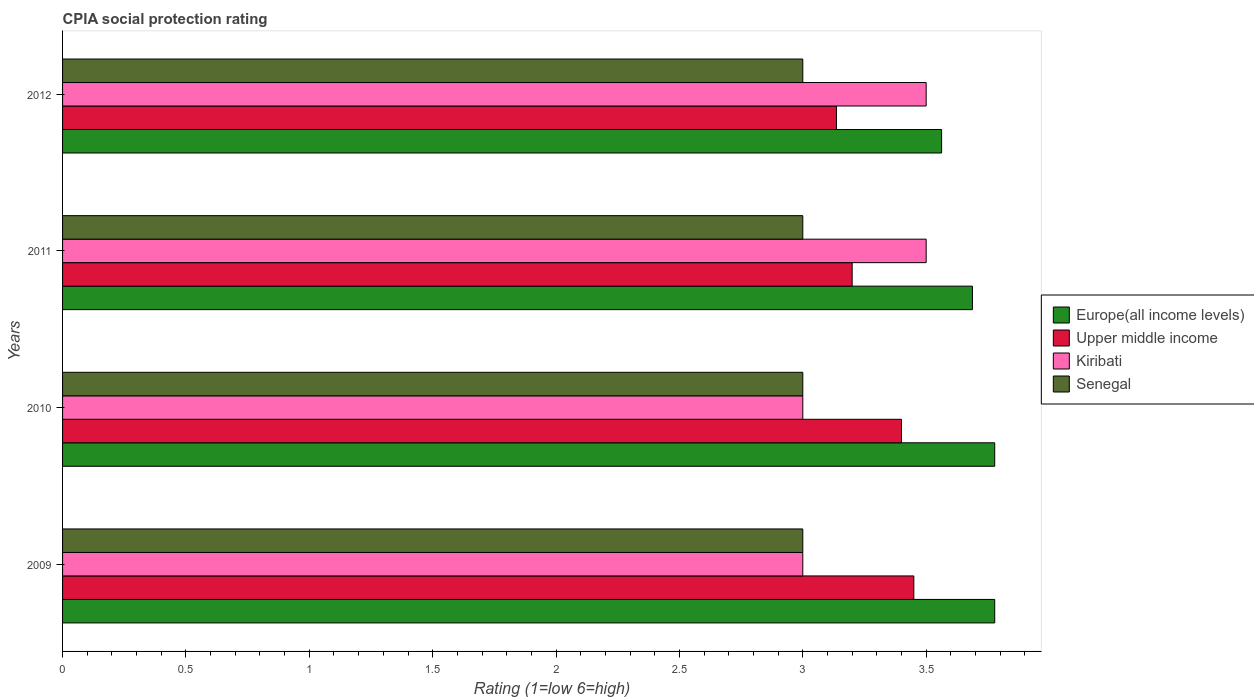Are the number of bars on each tick of the Y-axis equal?
Your answer should be very brief. Yes. How many bars are there on the 3rd tick from the bottom?
Offer a terse response. 4. In how many cases, is the number of bars for a given year not equal to the number of legend labels?
Provide a succinct answer. 0. What is the CPIA rating in Upper middle income in 2012?
Your response must be concise. 3.14. Across all years, what is the minimum CPIA rating in Senegal?
Make the answer very short. 3. In which year was the CPIA rating in Europe(all income levels) maximum?
Keep it short and to the point. 2009. What is the total CPIA rating in Senegal in the graph?
Give a very brief answer. 12. What is the difference between the CPIA rating in Upper middle income in 2009 and that in 2010?
Offer a terse response. 0.05. What is the difference between the CPIA rating in Upper middle income in 2009 and the CPIA rating in Kiribati in 2012?
Offer a terse response. -0.05. In the year 2011, what is the difference between the CPIA rating in Senegal and CPIA rating in Upper middle income?
Make the answer very short. -0.2. What is the ratio of the CPIA rating in Upper middle income in 2009 to that in 2012?
Ensure brevity in your answer.  1.1. What is the difference between the highest and the second highest CPIA rating in Upper middle income?
Offer a terse response. 0.05. What is the difference between the highest and the lowest CPIA rating in Upper middle income?
Provide a succinct answer. 0.31. Is the sum of the CPIA rating in Senegal in 2010 and 2012 greater than the maximum CPIA rating in Upper middle income across all years?
Offer a very short reply. Yes. Is it the case that in every year, the sum of the CPIA rating in Europe(all income levels) and CPIA rating in Senegal is greater than the sum of CPIA rating in Upper middle income and CPIA rating in Kiribati?
Your response must be concise. Yes. What does the 2nd bar from the top in 2011 represents?
Keep it short and to the point. Kiribati. What does the 1st bar from the bottom in 2009 represents?
Offer a very short reply. Europe(all income levels). Is it the case that in every year, the sum of the CPIA rating in Upper middle income and CPIA rating in Senegal is greater than the CPIA rating in Europe(all income levels)?
Keep it short and to the point. Yes. How many bars are there?
Provide a succinct answer. 16. Are all the bars in the graph horizontal?
Offer a terse response. Yes. What is the difference between two consecutive major ticks on the X-axis?
Make the answer very short. 0.5. Are the values on the major ticks of X-axis written in scientific E-notation?
Keep it short and to the point. No. Does the graph contain any zero values?
Ensure brevity in your answer.  No. Does the graph contain grids?
Give a very brief answer. No. How are the legend labels stacked?
Your answer should be compact. Vertical. What is the title of the graph?
Make the answer very short. CPIA social protection rating. Does "Cameroon" appear as one of the legend labels in the graph?
Give a very brief answer. No. What is the label or title of the Y-axis?
Make the answer very short. Years. What is the Rating (1=low 6=high) in Europe(all income levels) in 2009?
Your answer should be compact. 3.78. What is the Rating (1=low 6=high) in Upper middle income in 2009?
Your answer should be compact. 3.45. What is the Rating (1=low 6=high) of Kiribati in 2009?
Keep it short and to the point. 3. What is the Rating (1=low 6=high) of Senegal in 2009?
Make the answer very short. 3. What is the Rating (1=low 6=high) in Europe(all income levels) in 2010?
Your response must be concise. 3.78. What is the Rating (1=low 6=high) in Senegal in 2010?
Your response must be concise. 3. What is the Rating (1=low 6=high) of Europe(all income levels) in 2011?
Provide a succinct answer. 3.69. What is the Rating (1=low 6=high) in Kiribati in 2011?
Offer a very short reply. 3.5. What is the Rating (1=low 6=high) in Senegal in 2011?
Provide a short and direct response. 3. What is the Rating (1=low 6=high) of Europe(all income levels) in 2012?
Your response must be concise. 3.56. What is the Rating (1=low 6=high) of Upper middle income in 2012?
Provide a succinct answer. 3.14. Across all years, what is the maximum Rating (1=low 6=high) of Europe(all income levels)?
Your answer should be very brief. 3.78. Across all years, what is the maximum Rating (1=low 6=high) in Upper middle income?
Make the answer very short. 3.45. Across all years, what is the maximum Rating (1=low 6=high) in Kiribati?
Your answer should be compact. 3.5. Across all years, what is the maximum Rating (1=low 6=high) in Senegal?
Keep it short and to the point. 3. Across all years, what is the minimum Rating (1=low 6=high) of Europe(all income levels)?
Make the answer very short. 3.56. Across all years, what is the minimum Rating (1=low 6=high) of Upper middle income?
Your answer should be very brief. 3.14. Across all years, what is the minimum Rating (1=low 6=high) of Senegal?
Provide a succinct answer. 3. What is the total Rating (1=low 6=high) in Europe(all income levels) in the graph?
Ensure brevity in your answer.  14.81. What is the total Rating (1=low 6=high) of Upper middle income in the graph?
Keep it short and to the point. 13.19. What is the total Rating (1=low 6=high) in Kiribati in the graph?
Your response must be concise. 13. What is the difference between the Rating (1=low 6=high) of Upper middle income in 2009 and that in 2010?
Provide a short and direct response. 0.05. What is the difference between the Rating (1=low 6=high) of Kiribati in 2009 and that in 2010?
Your response must be concise. 0. What is the difference between the Rating (1=low 6=high) of Senegal in 2009 and that in 2010?
Keep it short and to the point. 0. What is the difference between the Rating (1=low 6=high) in Europe(all income levels) in 2009 and that in 2011?
Your answer should be very brief. 0.09. What is the difference between the Rating (1=low 6=high) in Senegal in 2009 and that in 2011?
Provide a short and direct response. 0. What is the difference between the Rating (1=low 6=high) of Europe(all income levels) in 2009 and that in 2012?
Keep it short and to the point. 0.22. What is the difference between the Rating (1=low 6=high) in Upper middle income in 2009 and that in 2012?
Keep it short and to the point. 0.31. What is the difference between the Rating (1=low 6=high) of Senegal in 2009 and that in 2012?
Your response must be concise. 0. What is the difference between the Rating (1=low 6=high) of Europe(all income levels) in 2010 and that in 2011?
Ensure brevity in your answer.  0.09. What is the difference between the Rating (1=low 6=high) of Upper middle income in 2010 and that in 2011?
Offer a terse response. 0.2. What is the difference between the Rating (1=low 6=high) of Senegal in 2010 and that in 2011?
Make the answer very short. 0. What is the difference between the Rating (1=low 6=high) in Europe(all income levels) in 2010 and that in 2012?
Your response must be concise. 0.22. What is the difference between the Rating (1=low 6=high) in Upper middle income in 2010 and that in 2012?
Keep it short and to the point. 0.26. What is the difference between the Rating (1=low 6=high) of Kiribati in 2010 and that in 2012?
Give a very brief answer. -0.5. What is the difference between the Rating (1=low 6=high) in Senegal in 2010 and that in 2012?
Offer a terse response. 0. What is the difference between the Rating (1=low 6=high) in Europe(all income levels) in 2011 and that in 2012?
Your response must be concise. 0.12. What is the difference between the Rating (1=low 6=high) in Upper middle income in 2011 and that in 2012?
Ensure brevity in your answer.  0.06. What is the difference between the Rating (1=low 6=high) of Kiribati in 2011 and that in 2012?
Give a very brief answer. 0. What is the difference between the Rating (1=low 6=high) in Europe(all income levels) in 2009 and the Rating (1=low 6=high) in Upper middle income in 2010?
Ensure brevity in your answer.  0.38. What is the difference between the Rating (1=low 6=high) of Europe(all income levels) in 2009 and the Rating (1=low 6=high) of Kiribati in 2010?
Provide a succinct answer. 0.78. What is the difference between the Rating (1=low 6=high) in Europe(all income levels) in 2009 and the Rating (1=low 6=high) in Senegal in 2010?
Keep it short and to the point. 0.78. What is the difference between the Rating (1=low 6=high) in Upper middle income in 2009 and the Rating (1=low 6=high) in Kiribati in 2010?
Your answer should be compact. 0.45. What is the difference between the Rating (1=low 6=high) in Upper middle income in 2009 and the Rating (1=low 6=high) in Senegal in 2010?
Offer a terse response. 0.45. What is the difference between the Rating (1=low 6=high) in Europe(all income levels) in 2009 and the Rating (1=low 6=high) in Upper middle income in 2011?
Offer a very short reply. 0.58. What is the difference between the Rating (1=low 6=high) in Europe(all income levels) in 2009 and the Rating (1=low 6=high) in Kiribati in 2011?
Offer a terse response. 0.28. What is the difference between the Rating (1=low 6=high) in Europe(all income levels) in 2009 and the Rating (1=low 6=high) in Senegal in 2011?
Your answer should be very brief. 0.78. What is the difference between the Rating (1=low 6=high) of Upper middle income in 2009 and the Rating (1=low 6=high) of Kiribati in 2011?
Your response must be concise. -0.05. What is the difference between the Rating (1=low 6=high) in Upper middle income in 2009 and the Rating (1=low 6=high) in Senegal in 2011?
Make the answer very short. 0.45. What is the difference between the Rating (1=low 6=high) in Europe(all income levels) in 2009 and the Rating (1=low 6=high) in Upper middle income in 2012?
Your response must be concise. 0.64. What is the difference between the Rating (1=low 6=high) in Europe(all income levels) in 2009 and the Rating (1=low 6=high) in Kiribati in 2012?
Offer a terse response. 0.28. What is the difference between the Rating (1=low 6=high) of Europe(all income levels) in 2009 and the Rating (1=low 6=high) of Senegal in 2012?
Provide a short and direct response. 0.78. What is the difference between the Rating (1=low 6=high) in Upper middle income in 2009 and the Rating (1=low 6=high) in Senegal in 2012?
Offer a very short reply. 0.45. What is the difference between the Rating (1=low 6=high) of Europe(all income levels) in 2010 and the Rating (1=low 6=high) of Upper middle income in 2011?
Make the answer very short. 0.58. What is the difference between the Rating (1=low 6=high) of Europe(all income levels) in 2010 and the Rating (1=low 6=high) of Kiribati in 2011?
Provide a short and direct response. 0.28. What is the difference between the Rating (1=low 6=high) in Upper middle income in 2010 and the Rating (1=low 6=high) in Kiribati in 2011?
Keep it short and to the point. -0.1. What is the difference between the Rating (1=low 6=high) of Upper middle income in 2010 and the Rating (1=low 6=high) of Senegal in 2011?
Give a very brief answer. 0.4. What is the difference between the Rating (1=low 6=high) of Europe(all income levels) in 2010 and the Rating (1=low 6=high) of Upper middle income in 2012?
Provide a succinct answer. 0.64. What is the difference between the Rating (1=low 6=high) in Europe(all income levels) in 2010 and the Rating (1=low 6=high) in Kiribati in 2012?
Keep it short and to the point. 0.28. What is the difference between the Rating (1=low 6=high) of Europe(all income levels) in 2010 and the Rating (1=low 6=high) of Senegal in 2012?
Ensure brevity in your answer.  0.78. What is the difference between the Rating (1=low 6=high) of Europe(all income levels) in 2011 and the Rating (1=low 6=high) of Upper middle income in 2012?
Your answer should be very brief. 0.55. What is the difference between the Rating (1=low 6=high) in Europe(all income levels) in 2011 and the Rating (1=low 6=high) in Kiribati in 2012?
Offer a very short reply. 0.19. What is the difference between the Rating (1=low 6=high) in Europe(all income levels) in 2011 and the Rating (1=low 6=high) in Senegal in 2012?
Ensure brevity in your answer.  0.69. What is the difference between the Rating (1=low 6=high) of Upper middle income in 2011 and the Rating (1=low 6=high) of Kiribati in 2012?
Ensure brevity in your answer.  -0.3. What is the average Rating (1=low 6=high) in Europe(all income levels) per year?
Make the answer very short. 3.7. What is the average Rating (1=low 6=high) of Upper middle income per year?
Keep it short and to the point. 3.3. In the year 2009, what is the difference between the Rating (1=low 6=high) in Europe(all income levels) and Rating (1=low 6=high) in Upper middle income?
Provide a succinct answer. 0.33. In the year 2009, what is the difference between the Rating (1=low 6=high) of Europe(all income levels) and Rating (1=low 6=high) of Kiribati?
Offer a very short reply. 0.78. In the year 2009, what is the difference between the Rating (1=low 6=high) of Upper middle income and Rating (1=low 6=high) of Kiribati?
Your response must be concise. 0.45. In the year 2009, what is the difference between the Rating (1=low 6=high) of Upper middle income and Rating (1=low 6=high) of Senegal?
Ensure brevity in your answer.  0.45. In the year 2010, what is the difference between the Rating (1=low 6=high) in Europe(all income levels) and Rating (1=low 6=high) in Upper middle income?
Provide a succinct answer. 0.38. In the year 2010, what is the difference between the Rating (1=low 6=high) in Upper middle income and Rating (1=low 6=high) in Senegal?
Your answer should be very brief. 0.4. In the year 2011, what is the difference between the Rating (1=low 6=high) in Europe(all income levels) and Rating (1=low 6=high) in Upper middle income?
Your response must be concise. 0.49. In the year 2011, what is the difference between the Rating (1=low 6=high) of Europe(all income levels) and Rating (1=low 6=high) of Kiribati?
Your response must be concise. 0.19. In the year 2011, what is the difference between the Rating (1=low 6=high) of Europe(all income levels) and Rating (1=low 6=high) of Senegal?
Provide a succinct answer. 0.69. In the year 2011, what is the difference between the Rating (1=low 6=high) in Upper middle income and Rating (1=low 6=high) in Senegal?
Provide a succinct answer. 0.2. In the year 2012, what is the difference between the Rating (1=low 6=high) of Europe(all income levels) and Rating (1=low 6=high) of Upper middle income?
Your answer should be very brief. 0.43. In the year 2012, what is the difference between the Rating (1=low 6=high) of Europe(all income levels) and Rating (1=low 6=high) of Kiribati?
Your answer should be very brief. 0.06. In the year 2012, what is the difference between the Rating (1=low 6=high) in Europe(all income levels) and Rating (1=low 6=high) in Senegal?
Give a very brief answer. 0.56. In the year 2012, what is the difference between the Rating (1=low 6=high) of Upper middle income and Rating (1=low 6=high) of Kiribati?
Make the answer very short. -0.36. In the year 2012, what is the difference between the Rating (1=low 6=high) in Upper middle income and Rating (1=low 6=high) in Senegal?
Keep it short and to the point. 0.14. In the year 2012, what is the difference between the Rating (1=low 6=high) in Kiribati and Rating (1=low 6=high) in Senegal?
Make the answer very short. 0.5. What is the ratio of the Rating (1=low 6=high) of Europe(all income levels) in 2009 to that in 2010?
Your response must be concise. 1. What is the ratio of the Rating (1=low 6=high) of Upper middle income in 2009 to that in 2010?
Your answer should be compact. 1.01. What is the ratio of the Rating (1=low 6=high) in Senegal in 2009 to that in 2010?
Provide a succinct answer. 1. What is the ratio of the Rating (1=low 6=high) in Europe(all income levels) in 2009 to that in 2011?
Give a very brief answer. 1.02. What is the ratio of the Rating (1=low 6=high) of Upper middle income in 2009 to that in 2011?
Your answer should be very brief. 1.08. What is the ratio of the Rating (1=low 6=high) in Senegal in 2009 to that in 2011?
Provide a succinct answer. 1. What is the ratio of the Rating (1=low 6=high) in Europe(all income levels) in 2009 to that in 2012?
Your answer should be very brief. 1.06. What is the ratio of the Rating (1=low 6=high) in Kiribati in 2009 to that in 2012?
Provide a succinct answer. 0.86. What is the ratio of the Rating (1=low 6=high) of Europe(all income levels) in 2010 to that in 2011?
Give a very brief answer. 1.02. What is the ratio of the Rating (1=low 6=high) of Upper middle income in 2010 to that in 2011?
Ensure brevity in your answer.  1.06. What is the ratio of the Rating (1=low 6=high) of Kiribati in 2010 to that in 2011?
Your answer should be compact. 0.86. What is the ratio of the Rating (1=low 6=high) in Senegal in 2010 to that in 2011?
Offer a very short reply. 1. What is the ratio of the Rating (1=low 6=high) of Europe(all income levels) in 2010 to that in 2012?
Your answer should be very brief. 1.06. What is the ratio of the Rating (1=low 6=high) in Upper middle income in 2010 to that in 2012?
Offer a very short reply. 1.08. What is the ratio of the Rating (1=low 6=high) in Senegal in 2010 to that in 2012?
Your answer should be very brief. 1. What is the ratio of the Rating (1=low 6=high) in Europe(all income levels) in 2011 to that in 2012?
Provide a short and direct response. 1.04. What is the ratio of the Rating (1=low 6=high) of Upper middle income in 2011 to that in 2012?
Your response must be concise. 1.02. What is the ratio of the Rating (1=low 6=high) of Kiribati in 2011 to that in 2012?
Offer a terse response. 1. What is the difference between the highest and the second highest Rating (1=low 6=high) of Upper middle income?
Offer a very short reply. 0.05. What is the difference between the highest and the second highest Rating (1=low 6=high) of Kiribati?
Offer a terse response. 0. What is the difference between the highest and the lowest Rating (1=low 6=high) of Europe(all income levels)?
Provide a short and direct response. 0.22. What is the difference between the highest and the lowest Rating (1=low 6=high) of Upper middle income?
Ensure brevity in your answer.  0.31. 